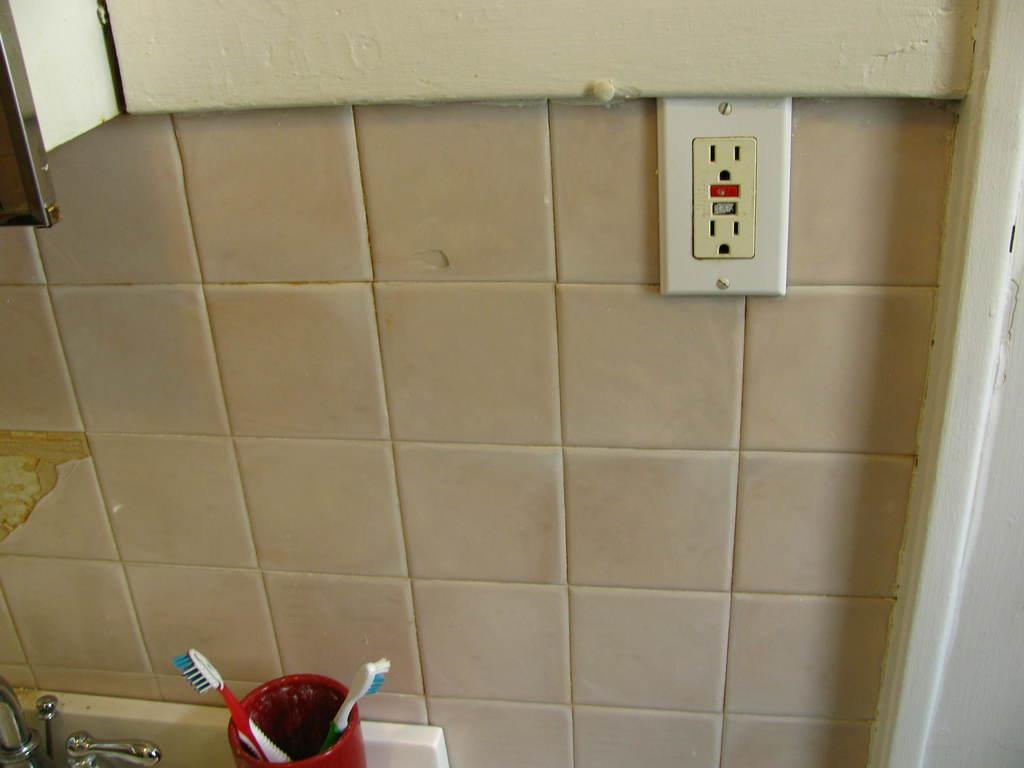What type of flooring is visible in the image? There are tiles in the image. Where is the tap located in the image? The tap is at the left bottom of the image. What is located next to the tap in the image? There is a brush stand at the left bottom of the image. How many brushes are in the brush stand? There are two brushes in the brush stand. What can be seen on the right side of the image? There is a socket board on the right side of the image. What type of disease is being treated in the image? There is no indication of a disease or treatment in the image; it features tiles, a tap, a brush stand, brushes, and a socket board. Can you tell me how many hydrants are visible in the image? There are no hydrants present in the image. 